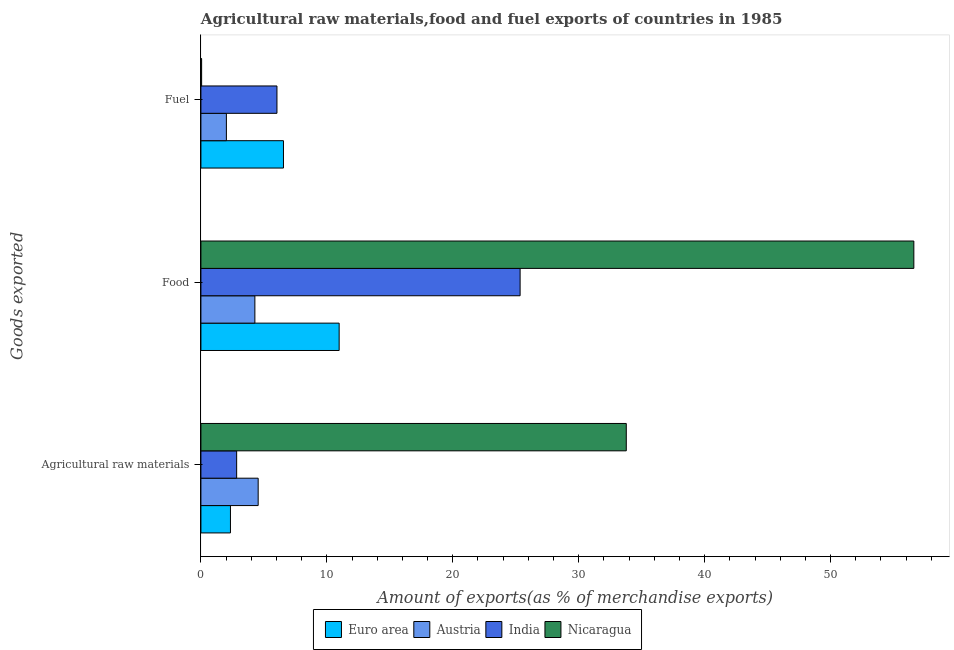How many different coloured bars are there?
Offer a very short reply. 4. How many bars are there on the 3rd tick from the bottom?
Your answer should be very brief. 4. What is the label of the 1st group of bars from the top?
Your answer should be compact. Fuel. What is the percentage of fuel exports in India?
Make the answer very short. 6.04. Across all countries, what is the maximum percentage of food exports?
Your answer should be very brief. 56.61. Across all countries, what is the minimum percentage of fuel exports?
Ensure brevity in your answer.  0.06. In which country was the percentage of food exports maximum?
Make the answer very short. Nicaragua. What is the total percentage of raw materials exports in the graph?
Provide a succinct answer. 43.51. What is the difference between the percentage of fuel exports in Austria and that in Euro area?
Keep it short and to the point. -4.53. What is the difference between the percentage of food exports in Nicaragua and the percentage of fuel exports in Austria?
Offer a very short reply. 54.59. What is the average percentage of food exports per country?
Offer a terse response. 24.3. What is the difference between the percentage of food exports and percentage of fuel exports in Euro area?
Make the answer very short. 4.42. What is the ratio of the percentage of raw materials exports in India to that in Euro area?
Your answer should be compact. 1.21. Is the difference between the percentage of food exports in India and Euro area greater than the difference between the percentage of fuel exports in India and Euro area?
Provide a short and direct response. Yes. What is the difference between the highest and the second highest percentage of fuel exports?
Provide a succinct answer. 0.52. What is the difference between the highest and the lowest percentage of fuel exports?
Give a very brief answer. 6.5. Is the sum of the percentage of food exports in Nicaragua and India greater than the maximum percentage of fuel exports across all countries?
Provide a short and direct response. Yes. Is it the case that in every country, the sum of the percentage of raw materials exports and percentage of food exports is greater than the percentage of fuel exports?
Your response must be concise. Yes. How many countries are there in the graph?
Provide a short and direct response. 4. Are the values on the major ticks of X-axis written in scientific E-notation?
Make the answer very short. No. How many legend labels are there?
Offer a terse response. 4. How are the legend labels stacked?
Give a very brief answer. Horizontal. What is the title of the graph?
Keep it short and to the point. Agricultural raw materials,food and fuel exports of countries in 1985. Does "Sri Lanka" appear as one of the legend labels in the graph?
Keep it short and to the point. No. What is the label or title of the X-axis?
Keep it short and to the point. Amount of exports(as % of merchandise exports). What is the label or title of the Y-axis?
Ensure brevity in your answer.  Goods exported. What is the Amount of exports(as % of merchandise exports) of Euro area in Agricultural raw materials?
Your answer should be compact. 2.35. What is the Amount of exports(as % of merchandise exports) of Austria in Agricultural raw materials?
Offer a very short reply. 4.55. What is the Amount of exports(as % of merchandise exports) of India in Agricultural raw materials?
Your answer should be very brief. 2.84. What is the Amount of exports(as % of merchandise exports) in Nicaragua in Agricultural raw materials?
Offer a terse response. 33.78. What is the Amount of exports(as % of merchandise exports) of Euro area in Food?
Provide a short and direct response. 10.98. What is the Amount of exports(as % of merchandise exports) in Austria in Food?
Keep it short and to the point. 4.28. What is the Amount of exports(as % of merchandise exports) in India in Food?
Provide a succinct answer. 25.35. What is the Amount of exports(as % of merchandise exports) of Nicaragua in Food?
Give a very brief answer. 56.61. What is the Amount of exports(as % of merchandise exports) in Euro area in Fuel?
Make the answer very short. 6.56. What is the Amount of exports(as % of merchandise exports) in Austria in Fuel?
Your answer should be very brief. 2.02. What is the Amount of exports(as % of merchandise exports) of India in Fuel?
Your response must be concise. 6.04. What is the Amount of exports(as % of merchandise exports) in Nicaragua in Fuel?
Offer a terse response. 0.06. Across all Goods exported, what is the maximum Amount of exports(as % of merchandise exports) in Euro area?
Your answer should be very brief. 10.98. Across all Goods exported, what is the maximum Amount of exports(as % of merchandise exports) in Austria?
Provide a succinct answer. 4.55. Across all Goods exported, what is the maximum Amount of exports(as % of merchandise exports) in India?
Your answer should be very brief. 25.35. Across all Goods exported, what is the maximum Amount of exports(as % of merchandise exports) in Nicaragua?
Provide a succinct answer. 56.61. Across all Goods exported, what is the minimum Amount of exports(as % of merchandise exports) of Euro area?
Ensure brevity in your answer.  2.35. Across all Goods exported, what is the minimum Amount of exports(as % of merchandise exports) of Austria?
Offer a very short reply. 2.02. Across all Goods exported, what is the minimum Amount of exports(as % of merchandise exports) in India?
Your response must be concise. 2.84. Across all Goods exported, what is the minimum Amount of exports(as % of merchandise exports) in Nicaragua?
Ensure brevity in your answer.  0.06. What is the total Amount of exports(as % of merchandise exports) in Euro area in the graph?
Offer a terse response. 19.88. What is the total Amount of exports(as % of merchandise exports) in Austria in the graph?
Provide a succinct answer. 10.85. What is the total Amount of exports(as % of merchandise exports) in India in the graph?
Provide a succinct answer. 34.22. What is the total Amount of exports(as % of merchandise exports) in Nicaragua in the graph?
Provide a short and direct response. 90.44. What is the difference between the Amount of exports(as % of merchandise exports) of Euro area in Agricultural raw materials and that in Food?
Provide a succinct answer. -8.63. What is the difference between the Amount of exports(as % of merchandise exports) in Austria in Agricultural raw materials and that in Food?
Your answer should be compact. 0.26. What is the difference between the Amount of exports(as % of merchandise exports) of India in Agricultural raw materials and that in Food?
Your answer should be compact. -22.51. What is the difference between the Amount of exports(as % of merchandise exports) in Nicaragua in Agricultural raw materials and that in Food?
Ensure brevity in your answer.  -22.83. What is the difference between the Amount of exports(as % of merchandise exports) in Euro area in Agricultural raw materials and that in Fuel?
Make the answer very short. -4.21. What is the difference between the Amount of exports(as % of merchandise exports) in Austria in Agricultural raw materials and that in Fuel?
Offer a very short reply. 2.52. What is the difference between the Amount of exports(as % of merchandise exports) of India in Agricultural raw materials and that in Fuel?
Ensure brevity in your answer.  -3.2. What is the difference between the Amount of exports(as % of merchandise exports) of Nicaragua in Agricultural raw materials and that in Fuel?
Offer a terse response. 33.72. What is the difference between the Amount of exports(as % of merchandise exports) of Euro area in Food and that in Fuel?
Offer a terse response. 4.42. What is the difference between the Amount of exports(as % of merchandise exports) of Austria in Food and that in Fuel?
Give a very brief answer. 2.26. What is the difference between the Amount of exports(as % of merchandise exports) of India in Food and that in Fuel?
Your response must be concise. 19.31. What is the difference between the Amount of exports(as % of merchandise exports) of Nicaragua in Food and that in Fuel?
Ensure brevity in your answer.  56.55. What is the difference between the Amount of exports(as % of merchandise exports) of Euro area in Agricultural raw materials and the Amount of exports(as % of merchandise exports) of Austria in Food?
Give a very brief answer. -1.94. What is the difference between the Amount of exports(as % of merchandise exports) in Euro area in Agricultural raw materials and the Amount of exports(as % of merchandise exports) in India in Food?
Keep it short and to the point. -23. What is the difference between the Amount of exports(as % of merchandise exports) of Euro area in Agricultural raw materials and the Amount of exports(as % of merchandise exports) of Nicaragua in Food?
Provide a short and direct response. -54.27. What is the difference between the Amount of exports(as % of merchandise exports) in Austria in Agricultural raw materials and the Amount of exports(as % of merchandise exports) in India in Food?
Your answer should be very brief. -20.8. What is the difference between the Amount of exports(as % of merchandise exports) of Austria in Agricultural raw materials and the Amount of exports(as % of merchandise exports) of Nicaragua in Food?
Your answer should be compact. -52.06. What is the difference between the Amount of exports(as % of merchandise exports) in India in Agricultural raw materials and the Amount of exports(as % of merchandise exports) in Nicaragua in Food?
Offer a very short reply. -53.77. What is the difference between the Amount of exports(as % of merchandise exports) in Euro area in Agricultural raw materials and the Amount of exports(as % of merchandise exports) in Austria in Fuel?
Keep it short and to the point. 0.32. What is the difference between the Amount of exports(as % of merchandise exports) in Euro area in Agricultural raw materials and the Amount of exports(as % of merchandise exports) in India in Fuel?
Offer a terse response. -3.69. What is the difference between the Amount of exports(as % of merchandise exports) of Euro area in Agricultural raw materials and the Amount of exports(as % of merchandise exports) of Nicaragua in Fuel?
Ensure brevity in your answer.  2.29. What is the difference between the Amount of exports(as % of merchandise exports) in Austria in Agricultural raw materials and the Amount of exports(as % of merchandise exports) in India in Fuel?
Provide a succinct answer. -1.49. What is the difference between the Amount of exports(as % of merchandise exports) in Austria in Agricultural raw materials and the Amount of exports(as % of merchandise exports) in Nicaragua in Fuel?
Your answer should be very brief. 4.49. What is the difference between the Amount of exports(as % of merchandise exports) of India in Agricultural raw materials and the Amount of exports(as % of merchandise exports) of Nicaragua in Fuel?
Make the answer very short. 2.78. What is the difference between the Amount of exports(as % of merchandise exports) of Euro area in Food and the Amount of exports(as % of merchandise exports) of Austria in Fuel?
Give a very brief answer. 8.95. What is the difference between the Amount of exports(as % of merchandise exports) in Euro area in Food and the Amount of exports(as % of merchandise exports) in India in Fuel?
Make the answer very short. 4.94. What is the difference between the Amount of exports(as % of merchandise exports) in Euro area in Food and the Amount of exports(as % of merchandise exports) in Nicaragua in Fuel?
Your answer should be compact. 10.92. What is the difference between the Amount of exports(as % of merchandise exports) in Austria in Food and the Amount of exports(as % of merchandise exports) in India in Fuel?
Provide a short and direct response. -1.75. What is the difference between the Amount of exports(as % of merchandise exports) of Austria in Food and the Amount of exports(as % of merchandise exports) of Nicaragua in Fuel?
Your response must be concise. 4.23. What is the difference between the Amount of exports(as % of merchandise exports) in India in Food and the Amount of exports(as % of merchandise exports) in Nicaragua in Fuel?
Your answer should be very brief. 25.29. What is the average Amount of exports(as % of merchandise exports) in Euro area per Goods exported?
Offer a terse response. 6.63. What is the average Amount of exports(as % of merchandise exports) of Austria per Goods exported?
Your response must be concise. 3.62. What is the average Amount of exports(as % of merchandise exports) in India per Goods exported?
Provide a short and direct response. 11.41. What is the average Amount of exports(as % of merchandise exports) of Nicaragua per Goods exported?
Provide a short and direct response. 30.15. What is the difference between the Amount of exports(as % of merchandise exports) of Euro area and Amount of exports(as % of merchandise exports) of Austria in Agricultural raw materials?
Ensure brevity in your answer.  -2.2. What is the difference between the Amount of exports(as % of merchandise exports) in Euro area and Amount of exports(as % of merchandise exports) in India in Agricultural raw materials?
Provide a succinct answer. -0.49. What is the difference between the Amount of exports(as % of merchandise exports) of Euro area and Amount of exports(as % of merchandise exports) of Nicaragua in Agricultural raw materials?
Your response must be concise. -31.43. What is the difference between the Amount of exports(as % of merchandise exports) in Austria and Amount of exports(as % of merchandise exports) in India in Agricultural raw materials?
Your answer should be very brief. 1.71. What is the difference between the Amount of exports(as % of merchandise exports) of Austria and Amount of exports(as % of merchandise exports) of Nicaragua in Agricultural raw materials?
Provide a short and direct response. -29.23. What is the difference between the Amount of exports(as % of merchandise exports) of India and Amount of exports(as % of merchandise exports) of Nicaragua in Agricultural raw materials?
Keep it short and to the point. -30.94. What is the difference between the Amount of exports(as % of merchandise exports) of Euro area and Amount of exports(as % of merchandise exports) of Austria in Food?
Your response must be concise. 6.69. What is the difference between the Amount of exports(as % of merchandise exports) of Euro area and Amount of exports(as % of merchandise exports) of India in Food?
Provide a short and direct response. -14.37. What is the difference between the Amount of exports(as % of merchandise exports) of Euro area and Amount of exports(as % of merchandise exports) of Nicaragua in Food?
Ensure brevity in your answer.  -45.63. What is the difference between the Amount of exports(as % of merchandise exports) of Austria and Amount of exports(as % of merchandise exports) of India in Food?
Your response must be concise. -21.06. What is the difference between the Amount of exports(as % of merchandise exports) of Austria and Amount of exports(as % of merchandise exports) of Nicaragua in Food?
Your response must be concise. -52.33. What is the difference between the Amount of exports(as % of merchandise exports) in India and Amount of exports(as % of merchandise exports) in Nicaragua in Food?
Offer a terse response. -31.26. What is the difference between the Amount of exports(as % of merchandise exports) of Euro area and Amount of exports(as % of merchandise exports) of Austria in Fuel?
Give a very brief answer. 4.53. What is the difference between the Amount of exports(as % of merchandise exports) in Euro area and Amount of exports(as % of merchandise exports) in India in Fuel?
Provide a succinct answer. 0.52. What is the difference between the Amount of exports(as % of merchandise exports) of Euro area and Amount of exports(as % of merchandise exports) of Nicaragua in Fuel?
Your answer should be compact. 6.5. What is the difference between the Amount of exports(as % of merchandise exports) in Austria and Amount of exports(as % of merchandise exports) in India in Fuel?
Make the answer very short. -4.02. What is the difference between the Amount of exports(as % of merchandise exports) in Austria and Amount of exports(as % of merchandise exports) in Nicaragua in Fuel?
Ensure brevity in your answer.  1.97. What is the difference between the Amount of exports(as % of merchandise exports) in India and Amount of exports(as % of merchandise exports) in Nicaragua in Fuel?
Keep it short and to the point. 5.98. What is the ratio of the Amount of exports(as % of merchandise exports) of Euro area in Agricultural raw materials to that in Food?
Your response must be concise. 0.21. What is the ratio of the Amount of exports(as % of merchandise exports) of Austria in Agricultural raw materials to that in Food?
Offer a very short reply. 1.06. What is the ratio of the Amount of exports(as % of merchandise exports) of India in Agricultural raw materials to that in Food?
Ensure brevity in your answer.  0.11. What is the ratio of the Amount of exports(as % of merchandise exports) of Nicaragua in Agricultural raw materials to that in Food?
Your answer should be very brief. 0.6. What is the ratio of the Amount of exports(as % of merchandise exports) in Euro area in Agricultural raw materials to that in Fuel?
Your answer should be compact. 0.36. What is the ratio of the Amount of exports(as % of merchandise exports) in Austria in Agricultural raw materials to that in Fuel?
Give a very brief answer. 2.25. What is the ratio of the Amount of exports(as % of merchandise exports) in India in Agricultural raw materials to that in Fuel?
Provide a short and direct response. 0.47. What is the ratio of the Amount of exports(as % of merchandise exports) of Nicaragua in Agricultural raw materials to that in Fuel?
Your answer should be compact. 594.84. What is the ratio of the Amount of exports(as % of merchandise exports) in Euro area in Food to that in Fuel?
Provide a short and direct response. 1.67. What is the ratio of the Amount of exports(as % of merchandise exports) in Austria in Food to that in Fuel?
Your answer should be compact. 2.12. What is the ratio of the Amount of exports(as % of merchandise exports) of India in Food to that in Fuel?
Provide a short and direct response. 4.2. What is the ratio of the Amount of exports(as % of merchandise exports) of Nicaragua in Food to that in Fuel?
Keep it short and to the point. 996.97. What is the difference between the highest and the second highest Amount of exports(as % of merchandise exports) of Euro area?
Offer a very short reply. 4.42. What is the difference between the highest and the second highest Amount of exports(as % of merchandise exports) of Austria?
Provide a short and direct response. 0.26. What is the difference between the highest and the second highest Amount of exports(as % of merchandise exports) in India?
Your response must be concise. 19.31. What is the difference between the highest and the second highest Amount of exports(as % of merchandise exports) in Nicaragua?
Your answer should be compact. 22.83. What is the difference between the highest and the lowest Amount of exports(as % of merchandise exports) in Euro area?
Offer a terse response. 8.63. What is the difference between the highest and the lowest Amount of exports(as % of merchandise exports) in Austria?
Provide a succinct answer. 2.52. What is the difference between the highest and the lowest Amount of exports(as % of merchandise exports) in India?
Provide a succinct answer. 22.51. What is the difference between the highest and the lowest Amount of exports(as % of merchandise exports) in Nicaragua?
Make the answer very short. 56.55. 